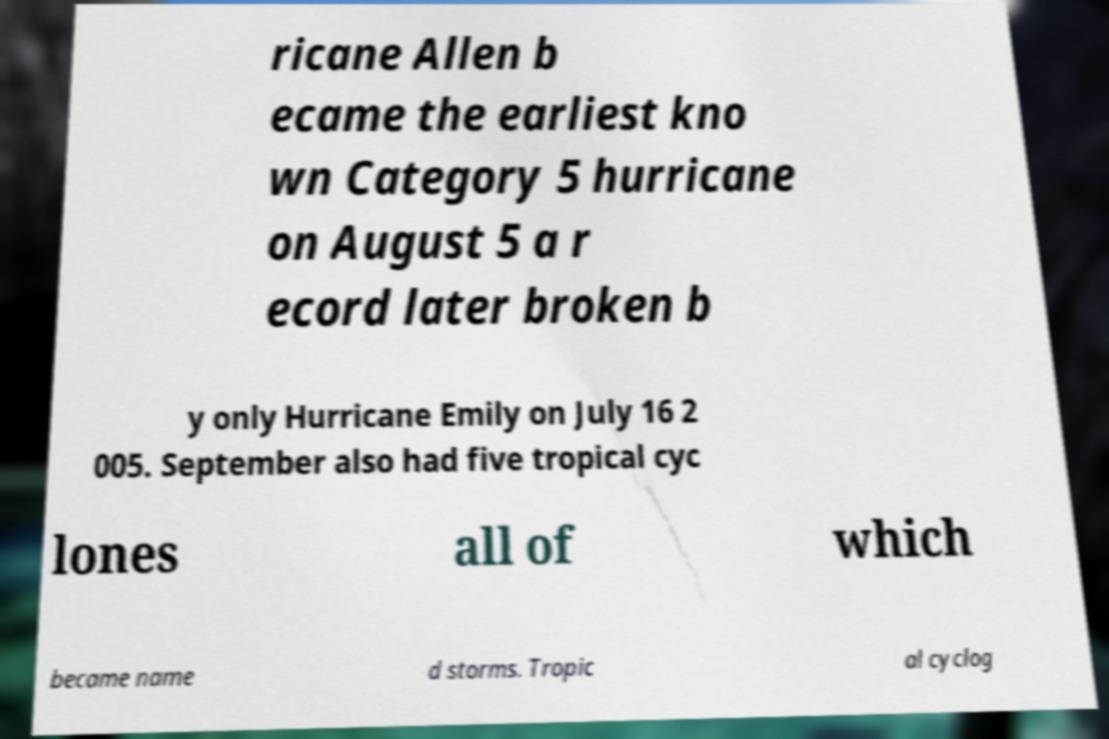For documentation purposes, I need the text within this image transcribed. Could you provide that? ricane Allen b ecame the earliest kno wn Category 5 hurricane on August 5 a r ecord later broken b y only Hurricane Emily on July 16 2 005. September also had five tropical cyc lones all of which became name d storms. Tropic al cyclog 